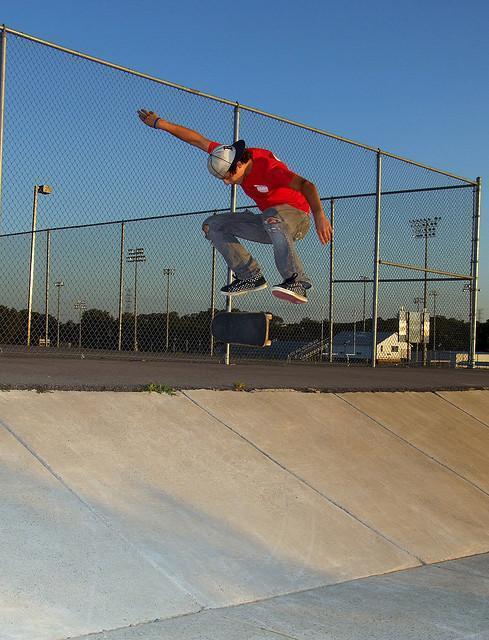How many faces of the clock can you see completely?
Give a very brief answer. 0. 